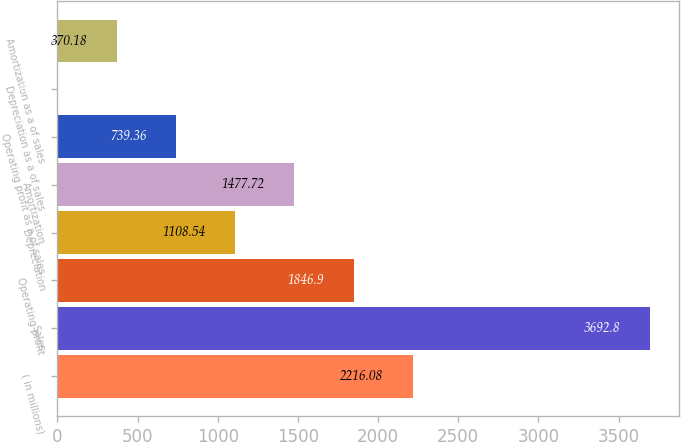<chart> <loc_0><loc_0><loc_500><loc_500><bar_chart><fcel>( in millions)<fcel>Sales<fcel>Operating profit<fcel>Depreciation<fcel>Amortization<fcel>Operating profit as a of sales<fcel>Depreciation as a of sales<fcel>Amortization as a of sales<nl><fcel>2216.08<fcel>3692.8<fcel>1846.9<fcel>1108.54<fcel>1477.72<fcel>739.36<fcel>1<fcel>370.18<nl></chart> 